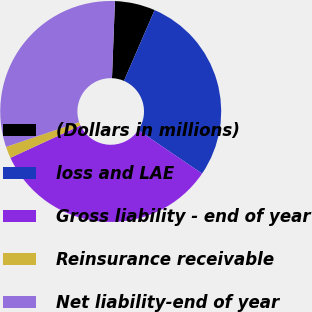Convert chart. <chart><loc_0><loc_0><loc_500><loc_500><pie_chart><fcel>(Dollars in millions)<fcel>loss and LAE<fcel>Gross liability - end of year<fcel>Reinsurance receivable<fcel>Net liability-end of year<nl><fcel>5.89%<fcel>28.0%<fcel>33.6%<fcel>1.7%<fcel>30.8%<nl></chart> 